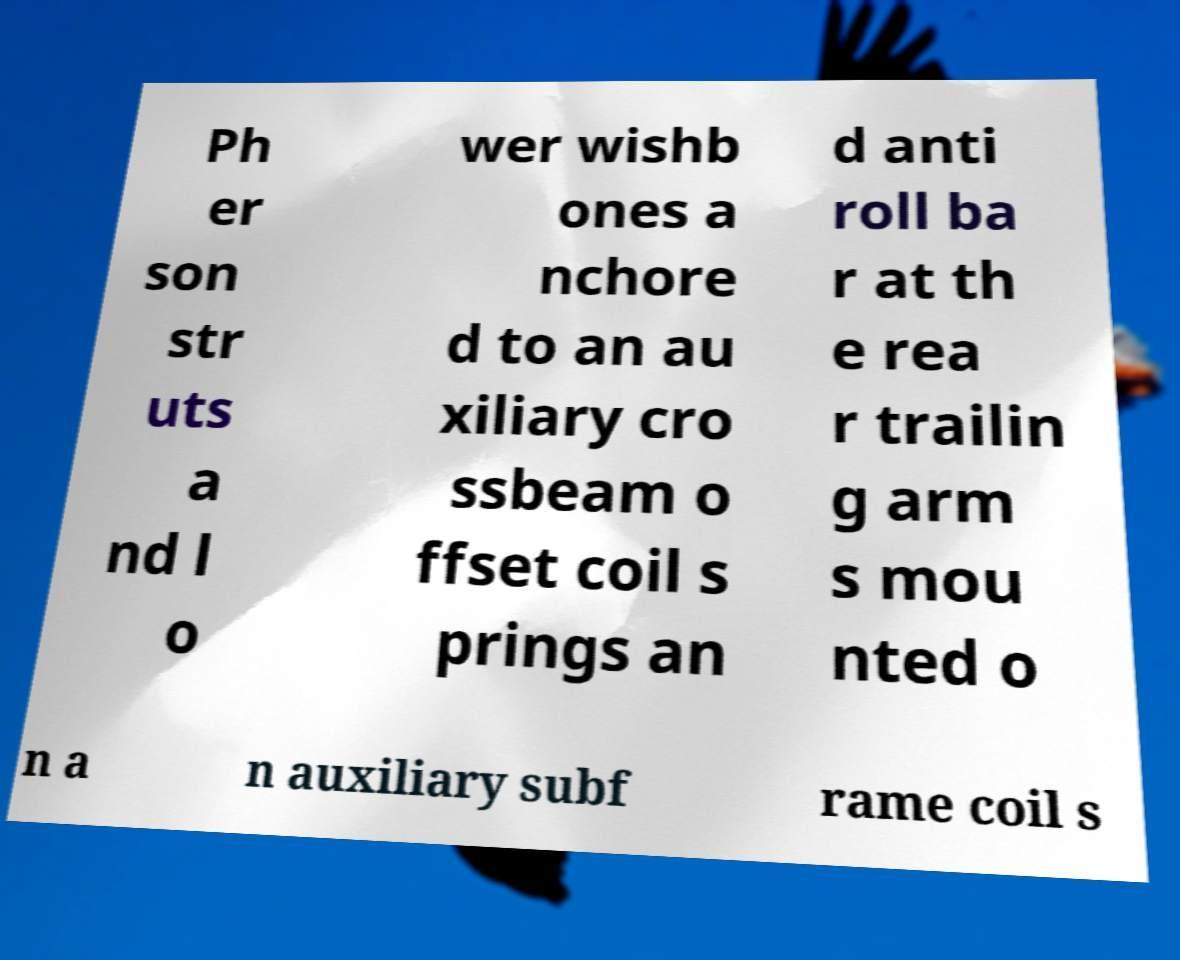There's text embedded in this image that I need extracted. Can you transcribe it verbatim? Ph er son str uts a nd l o wer wishb ones a nchore d to an au xiliary cro ssbeam o ffset coil s prings an d anti roll ba r at th e rea r trailin g arm s mou nted o n a n auxiliary subf rame coil s 